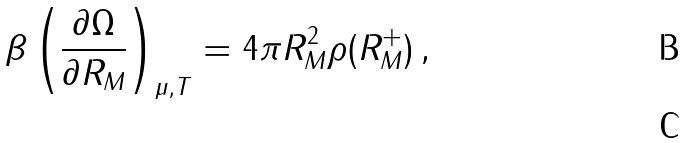Convert formula to latex. <formula><loc_0><loc_0><loc_500><loc_500>\beta \left ( \frac { \partial \Omega } { \partial R _ { M } } \right ) _ { \mu , T } = 4 \pi R _ { M } ^ { 2 } \rho ( R _ { M } ^ { + } ) \, , \\</formula> 